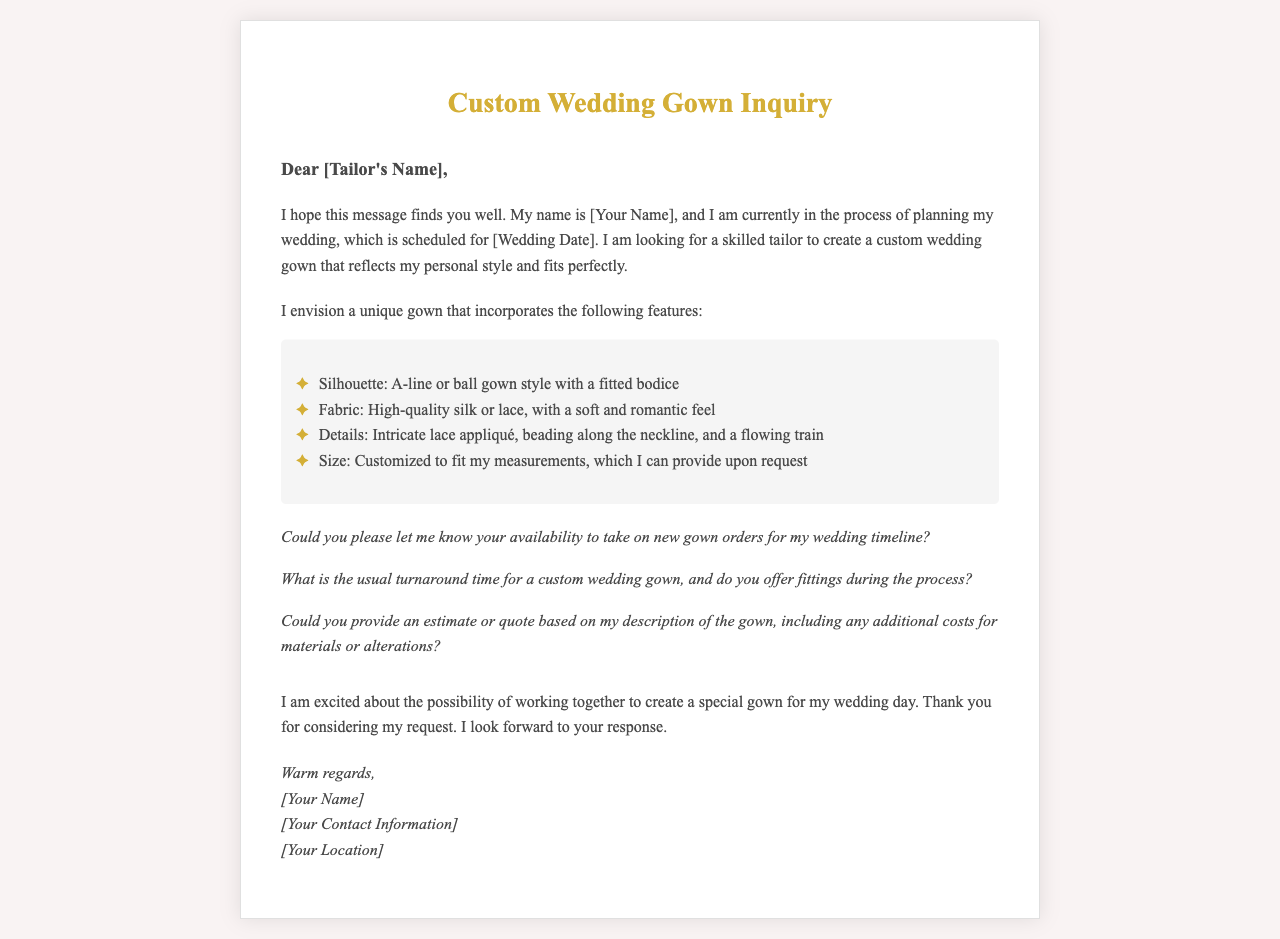What is the scheduled wedding date? The wedding date is mentioned as [Wedding Date] in the introduction.
Answer: [Wedding Date] What silhouette does the bride envision for the gown? The envisioned silhouette described is either A-line or ball gown style with a fitted bodice.
Answer: A-line or ball gown What fabric is preferred for the wedding gown? The preferred fabric stated in the letter is high-quality silk or lace.
Answer: High-quality silk or lace What details are requested for the gown? The letter mentions specific details such as intricate lace appliqué, beading along the neckline, and a flowing train.
Answer: Intricate lace appliqué, beading along the neckline, and a flowing train What does the bride want to provide for customization? The bride mentions that she can provide her measurements for customization.
Answer: Measurements What is the inquiry about the tailor's availability? The bride asks if the tailor is available to take on new gown orders for her wedding timeline.
Answer: Availability for new gown orders What type of fitting does the bride inquire about? The bride inquires whether the tailor offers fittings during the process of creating the gown.
Answer: Fittings during the process What is requested in terms of a quote? The bride asks for an estimate or quote based on her description of the gown.
Answer: Estimate or quote What is the tone of the closing remarks? The closing remarks convey excitement and gratitude towards the tailor for considering the request.
Answer: Excitement and gratitude 